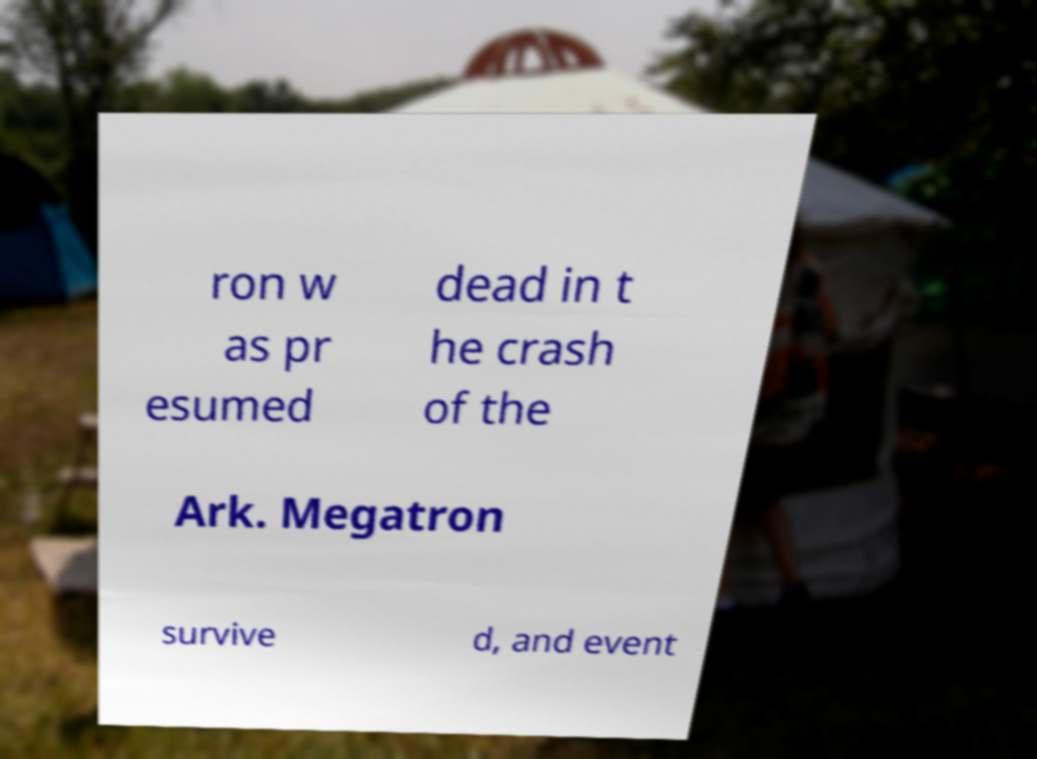Could you extract and type out the text from this image? ron w as pr esumed dead in t he crash of the Ark. Megatron survive d, and event 